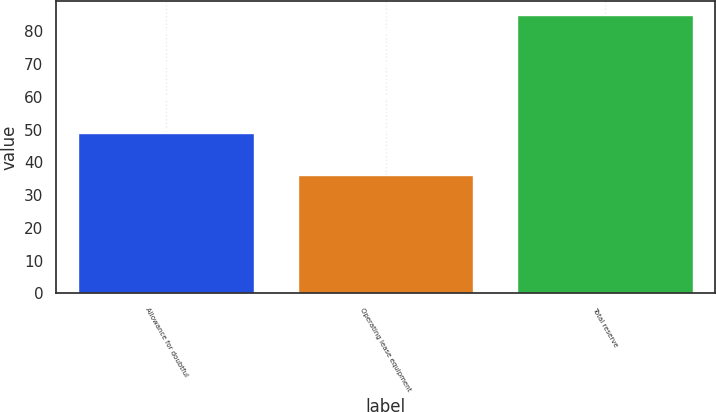Convert chart. <chart><loc_0><loc_0><loc_500><loc_500><bar_chart><fcel>Allowance for doubtful<fcel>Operating lease equipment<fcel>Total reserve<nl><fcel>49<fcel>36<fcel>85<nl></chart> 